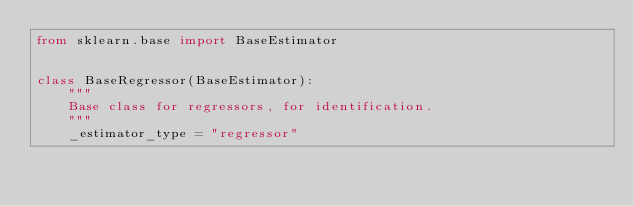<code> <loc_0><loc_0><loc_500><loc_500><_Python_>from sklearn.base import BaseEstimator


class BaseRegressor(BaseEstimator):
    """
    Base class for regressors, for identification.
    """
    _estimator_type = "regressor"</code> 